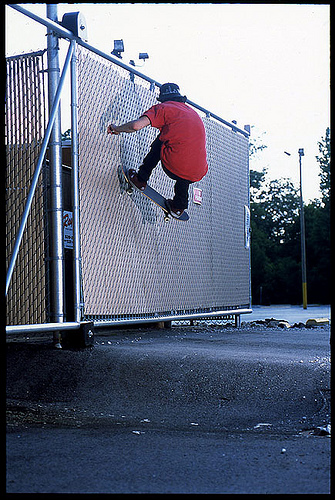Extract all visible text content from this image. Rey 